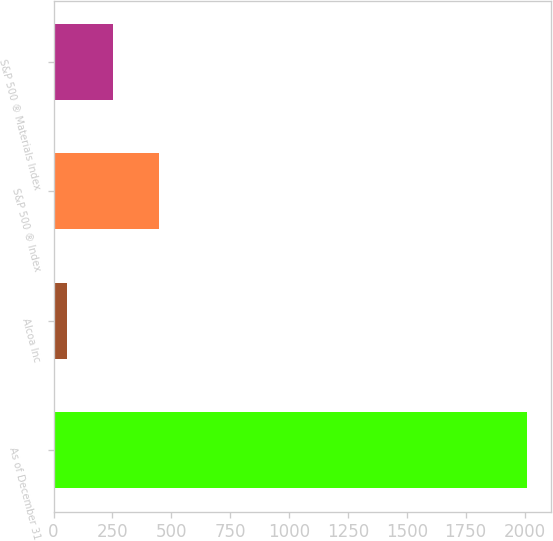Convert chart to OTSL. <chart><loc_0><loc_0><loc_500><loc_500><bar_chart><fcel>As of December 31<fcel>Alcoa Inc<fcel>S&P 500 ® Index<fcel>S&P 500 ® Materials Index<nl><fcel>2011<fcel>57<fcel>447.8<fcel>252.4<nl></chart> 